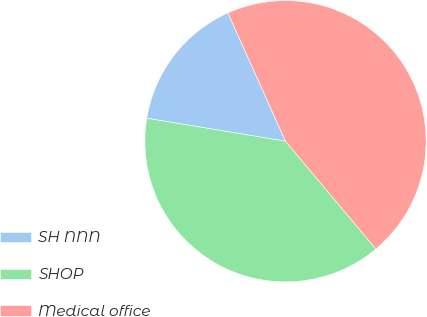Convert chart to OTSL. <chart><loc_0><loc_0><loc_500><loc_500><pie_chart><fcel>SH NNN<fcel>SHOP<fcel>Medical office<nl><fcel>15.67%<fcel>38.72%<fcel>45.61%<nl></chart> 